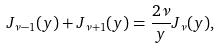<formula> <loc_0><loc_0><loc_500><loc_500>J _ { \nu - 1 } ( y ) + J _ { \nu + 1 } ( y ) = \frac { 2 \nu } { y } J _ { \nu } ( y ) ,</formula> 